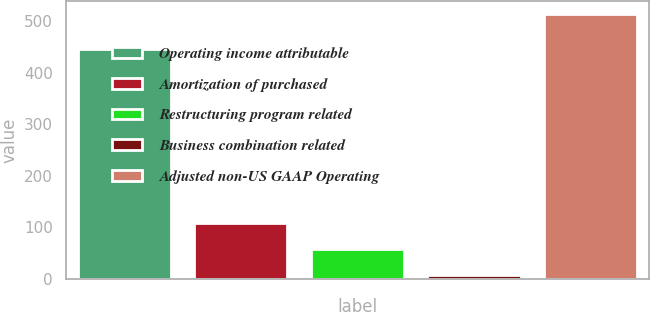Convert chart. <chart><loc_0><loc_0><loc_500><loc_500><bar_chart><fcel>Operating income attributable<fcel>Amortization of purchased<fcel>Restructuring program related<fcel>Business combination related<fcel>Adjusted non-US GAAP Operating<nl><fcel>445.6<fcel>108<fcel>57.4<fcel>6.8<fcel>512.8<nl></chart> 